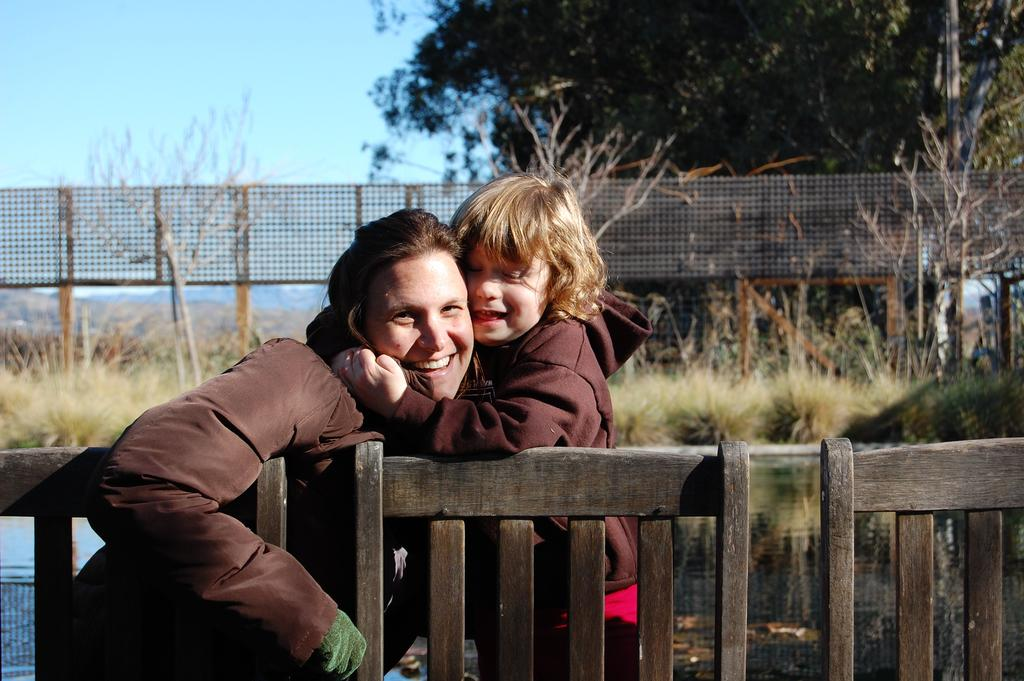What is the main subject of the image? There is a kid in the image. What is the emotional state of the kid in the image? The kid is smiling. Are there any other people in the image? Yes, there is a woman in the image. What is the emotional state of the woman in the image? The woman is smiling. What type of objects can be seen in the image? There are wooden objects in the image. What natural elements are present in the image? There is water, grass, and trees in the image. What architectural feature is visible in the image? There is a fence in the image. What can be seen in the background of the image? There are trees and the sky visible in the background of the image. What type of war is being fought in the background of the image? There is no war present in the image; it features a kid, a woman, wooden objects, water, grass, a fence, trees, and the sky. How many fingers does the kid have on their left hand in the image? The image does not show the kid's fingers, so it cannot be determined from the image. 